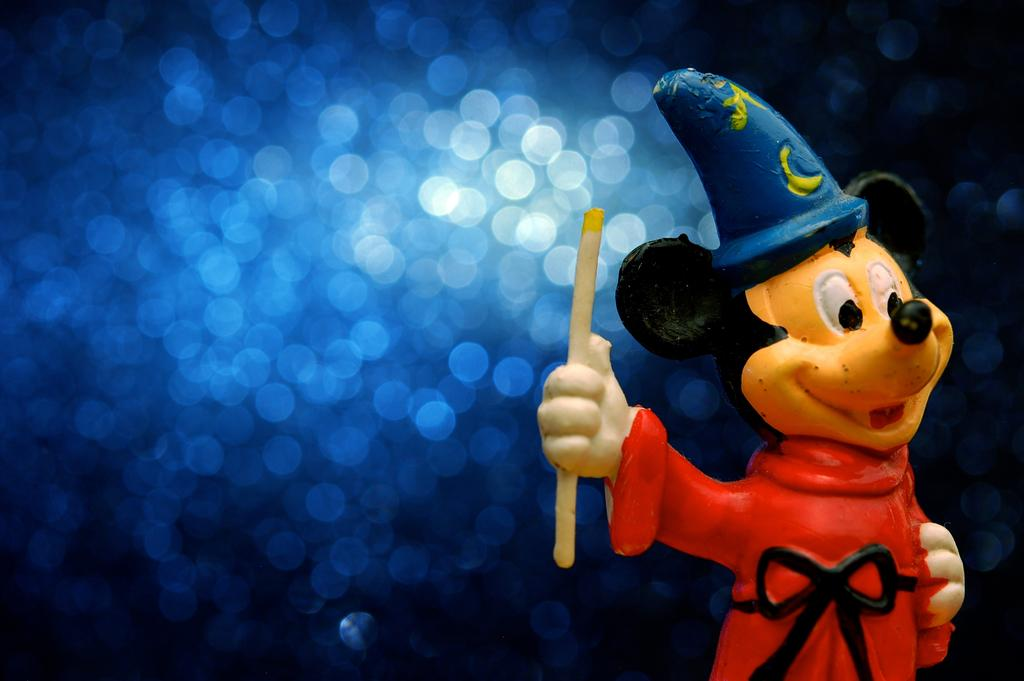What character is depicted in the image? There is a Mickey Mouse figure in the image. What accessory is the Mickey Mouse figure wearing? The Mickey Mouse figure is wearing a cap. What object is the Mickey Mouse figure holding? The Mickey Mouse figure is holding a stick. Can you describe the background of the image? The background of the image is blurry. What type of nut is being discussed by the Mickey Mouse figure in the image? There is no discussion or nut present in the image; it only features the Mickey Mouse figure holding a stick. 